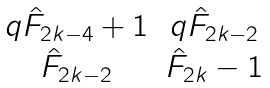<formula> <loc_0><loc_0><loc_500><loc_500>\begin{matrix} q \hat { F } _ { 2 k - 4 } + 1 & q \hat { F } _ { 2 k - 2 } \\ \hat { F } _ { 2 k - 2 } & \hat { F } _ { 2 k } - 1 \end{matrix}</formula> 